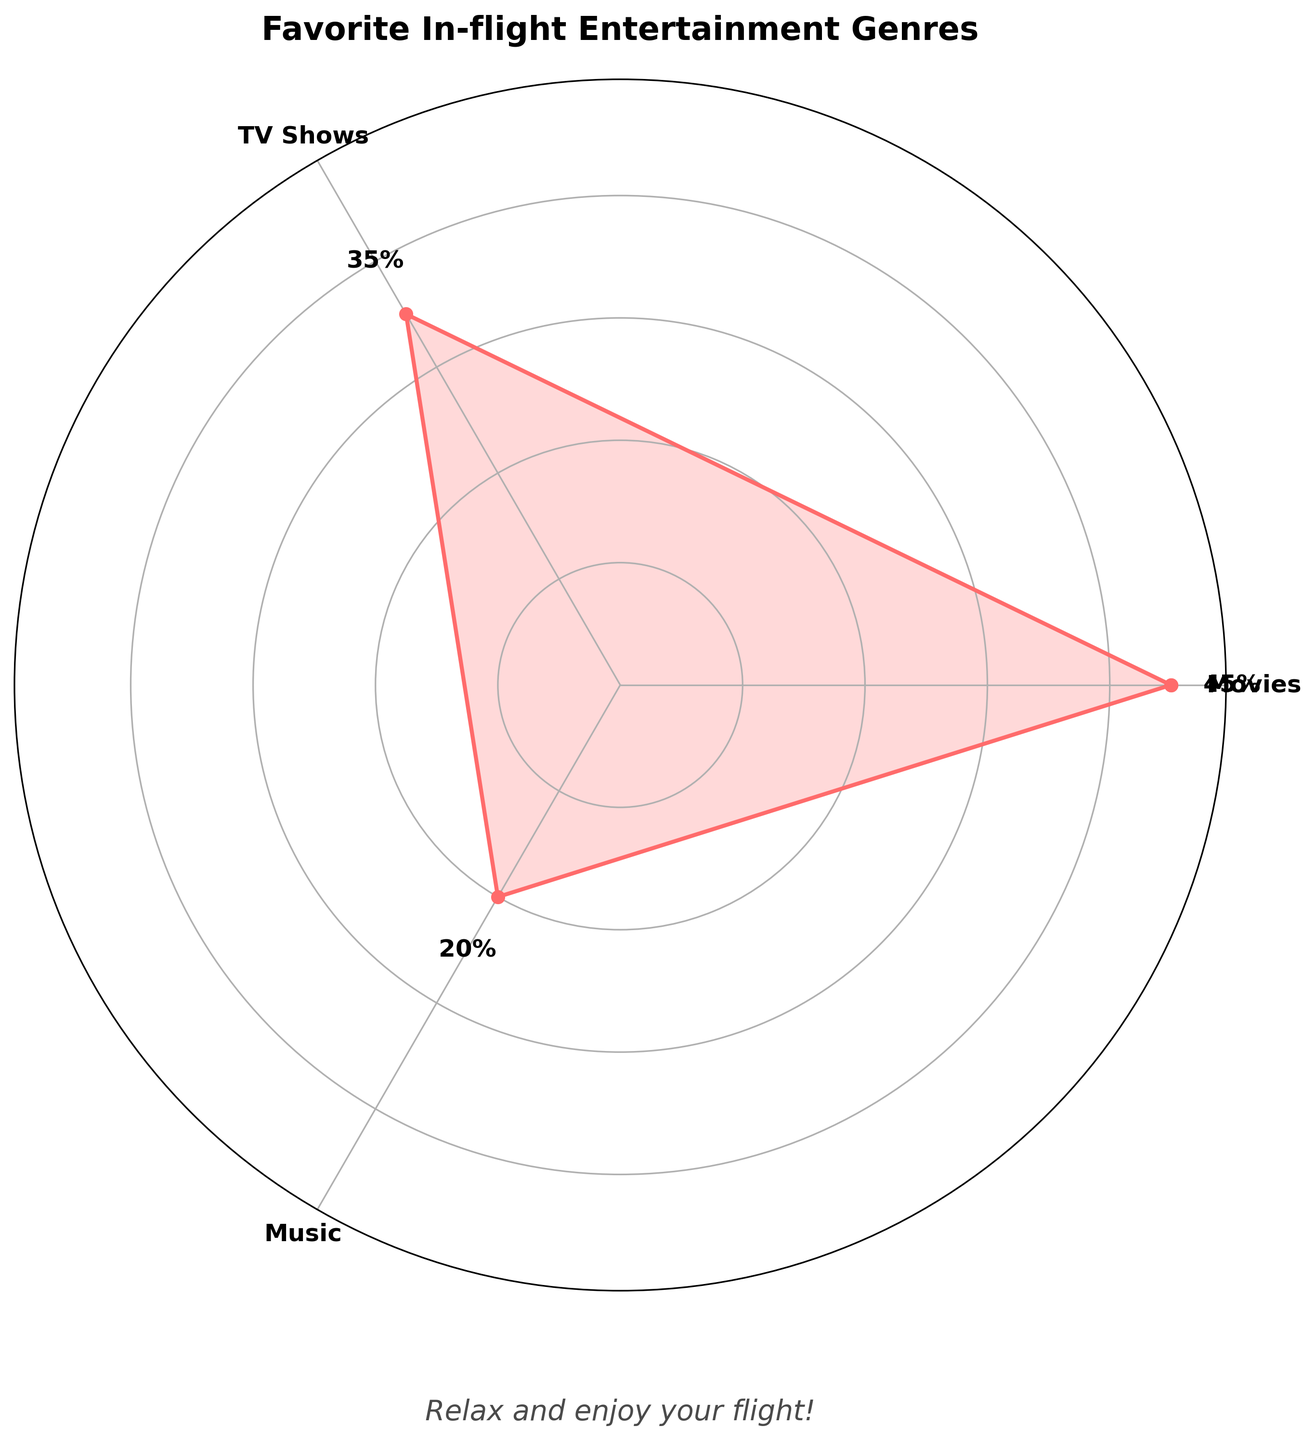What's the title of the figure? The title is prominently displayed at the top of the chart in bold font.
Answer: Favorite In-flight Entertainment Genres What is the most popular genre among passengers? The highest percentage on the chart corresponds to the most popular genre. Movies have the highest percentage at 45%.
Answer: Movies How much more popular are movies compared to music? Subtract the percentage of music from the percentage of movies (45% - 20%).
Answer: 25% Which genre is the least popular? The genre with the smallest percentage value is the least popular. Music has the lowest percentage at 20%.
Answer: Music What angle (in degrees) does the genre TV Shows occupy in the chart? The chart is a rose plot which is divided into equal parts by genres. Each genre occupies an angle based on 360 degrees. TV Shows is one of the three genres (360/3).
Answer: 120 degrees What’s the total percentage covered by movies and TV shows combined? Add the percentages of movies and TV shows (45% + 35%).
Answer: 80% Which genres have a combined total percentage exceeding 50%? Summing the percentages of Movies and TV Shows gives 45% + 35% = 80%, which is more than 50%.
Answer: Movies and TV Shows How much less popular is TV Shows than Movies? Subtract the percentage of TV Shows from the percentage of Movies (45% - 35%).
Answer: 10% How many genres are depicted in this rose chart? The number of unique labels (genres) displayed on the chart.
Answer: 3 What calming message is included in the chart for nervous fliers? A calming text is added at the bottom of the chart to comfort nervous passengers.
Answer: Relax and enjoy your flight! 